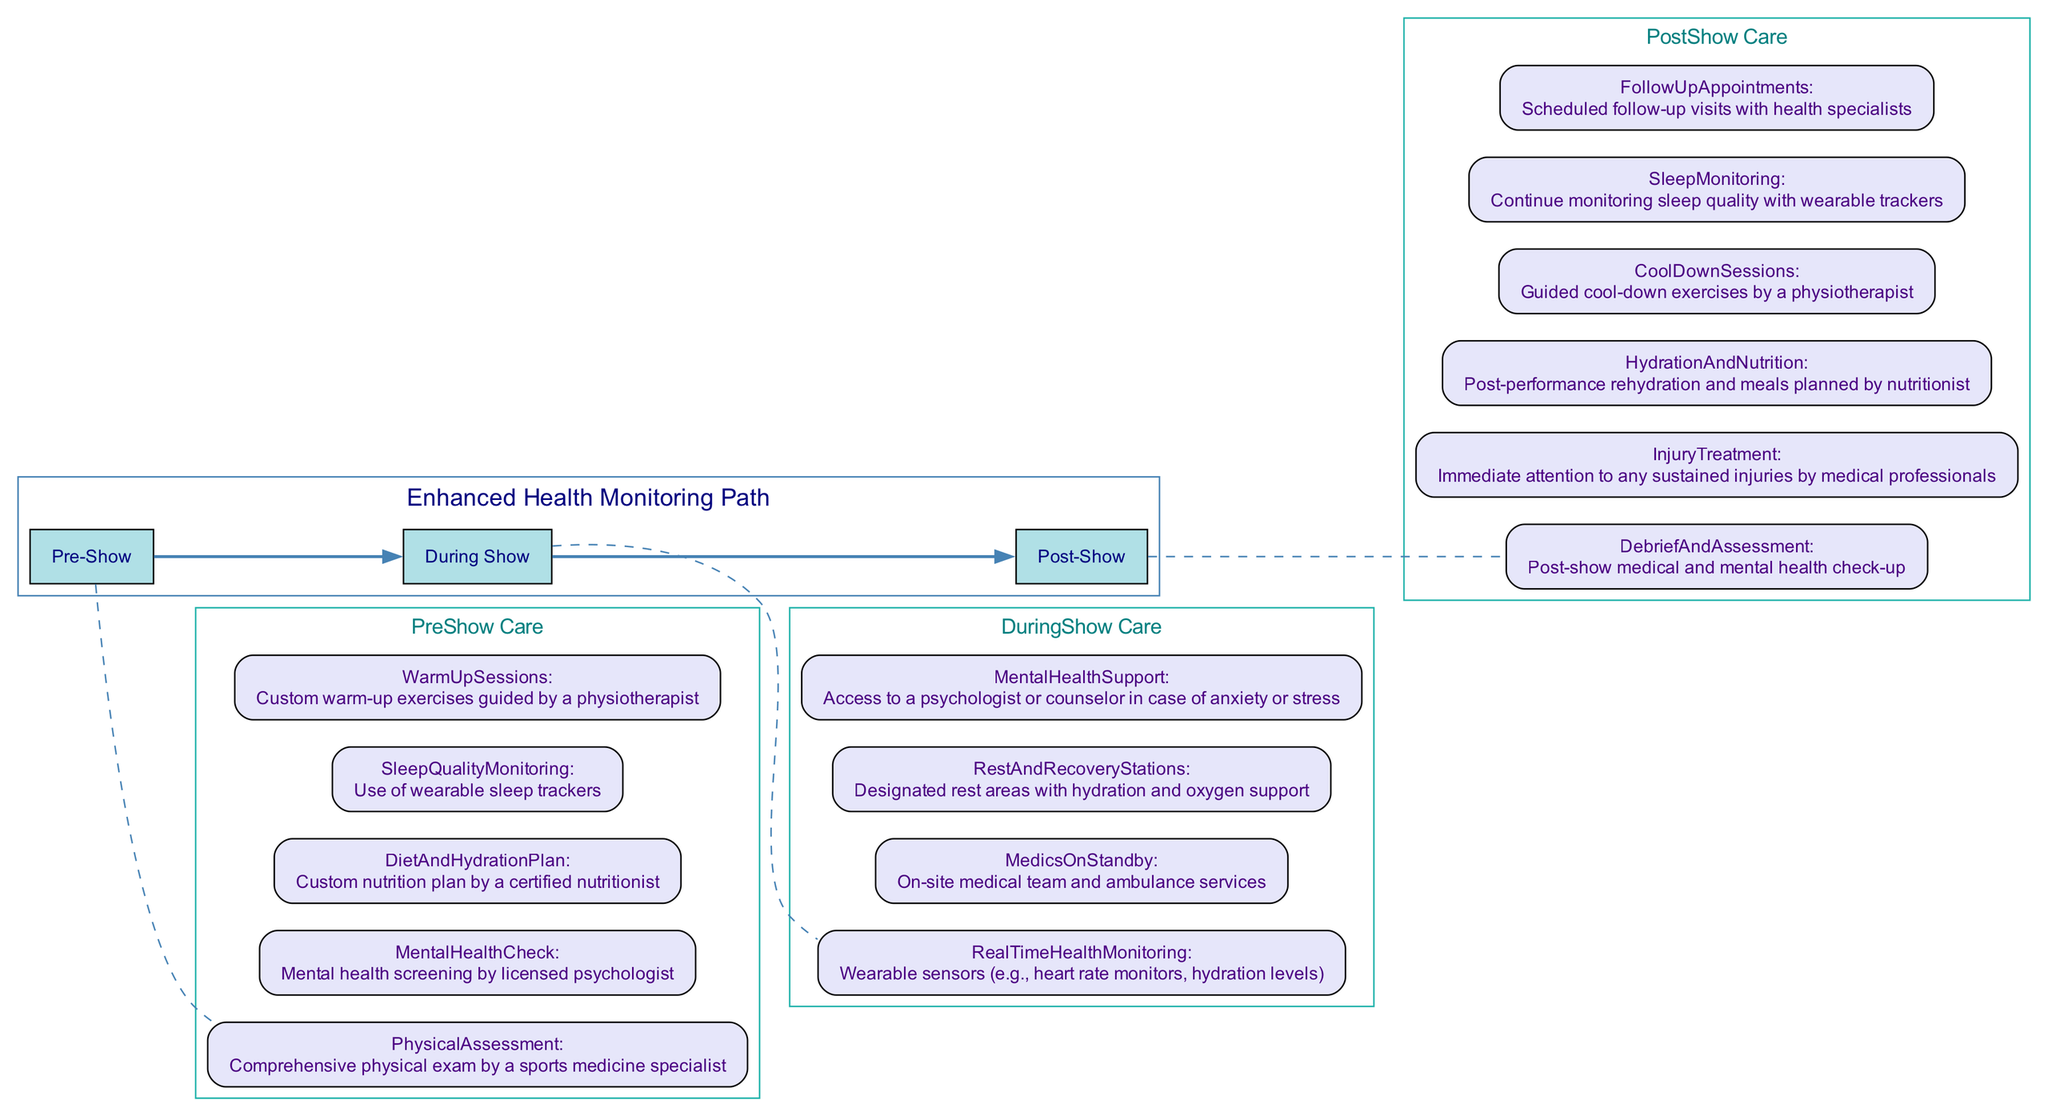What are the three main stages of the Enhanced Health Monitoring Path? The diagram clearly labels three stages: Pre-Show, During Show, and Post-Show. These stages are connected sequentially, indicating the flow of the health monitoring process.
Answer: Pre-Show, During Show, Post-Show How many care types are listed under Pre-Show Care? The diagram lists five specific care items under the Pre-Show Care category, each detailing different aspects of care for performers before a show.
Answer: 5 Which professional is responsible for the Mental Health Check in Pre-Show Care? According to the diagram, the Mental Health Check is conducted by a licensed psychologist, as indicated in the description attached to that care item.
Answer: Licensed psychologist What type of monitoring is used for Sleep Quality Monitoring? The diagram specifies that wearable sleep trackers are employed for monitoring sleep quality, indicating the technology used for this purpose in pre-show care.
Answer: Wearable sleep trackers How is Real-Time Health Monitoring conducted during the show? The diagram indicates that wearable sensors, such as heart rate monitors and hydration levels, are utilized for Real-Time Health Monitoring, providing a technological approach to monitoring performers' health during the show.
Answer: Wearable sensors What specific support is provided for mental health during the show? The diagram states that access to a psychologist or counselor is available for performers in case of anxiety or stress, which emphasizes the importance of mental health support during the show.
Answer: Access to a psychologist or counselor What happens at the Debrief and Assessment stage in Post-Show Care? The Debrief and Assessment stage involves a post-show medical and mental health check-up, indicating the concern for the performers' well-being after the performance.
Answer: Post-show medical and mental health check-up How many nodes are there in the During Show Care section? The During Show Care section includes four distinct care items that are connected under this category, highlighting the various forms of support available during the performance.
Answer: 4 Which professional is responsible for Cool Down Sessions after the show? The diagram indicates that guided cool-down exercises are conducted by a physiotherapist, making it clear who oversees this aspect of post-show care.
Answer: Physiotherapist 